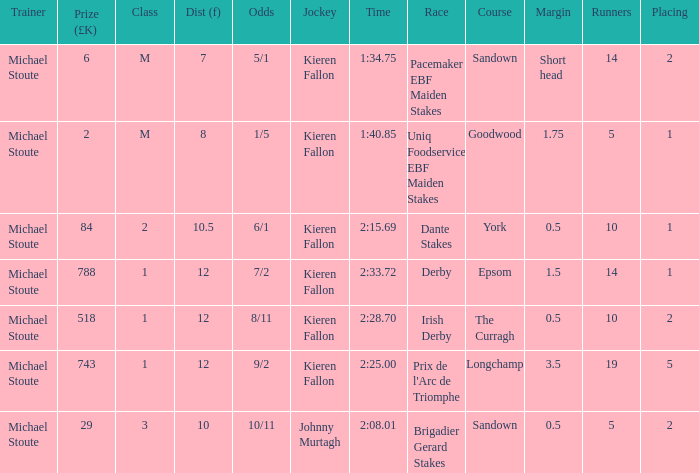Name the runners for longchamp 19.0. 